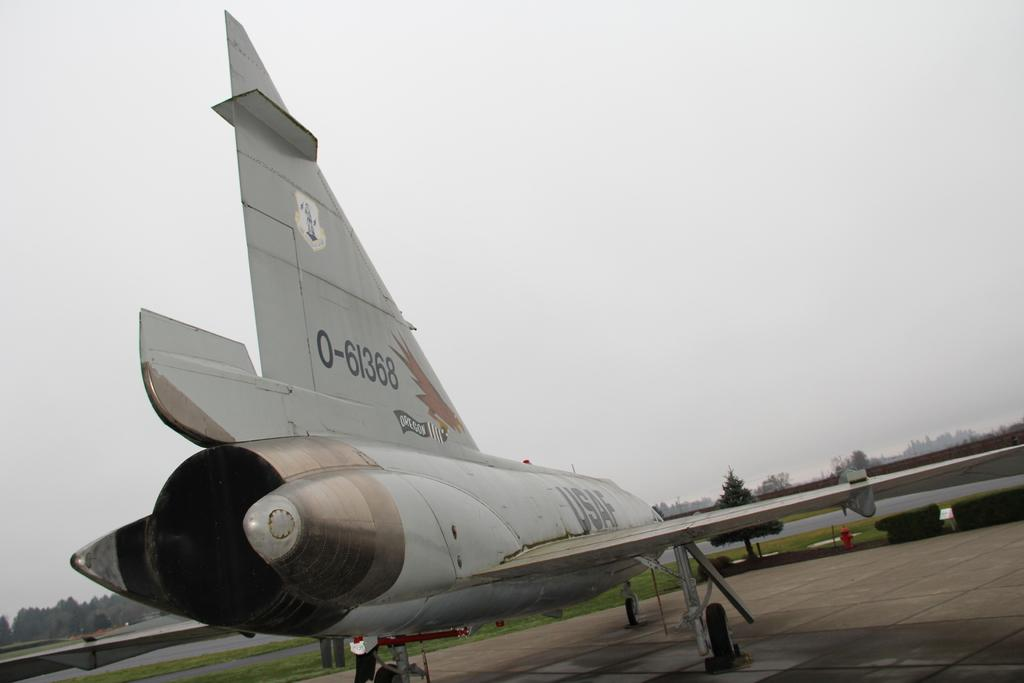<image>
Write a terse but informative summary of the picture. A plane with the number 0-61368 on its tail 